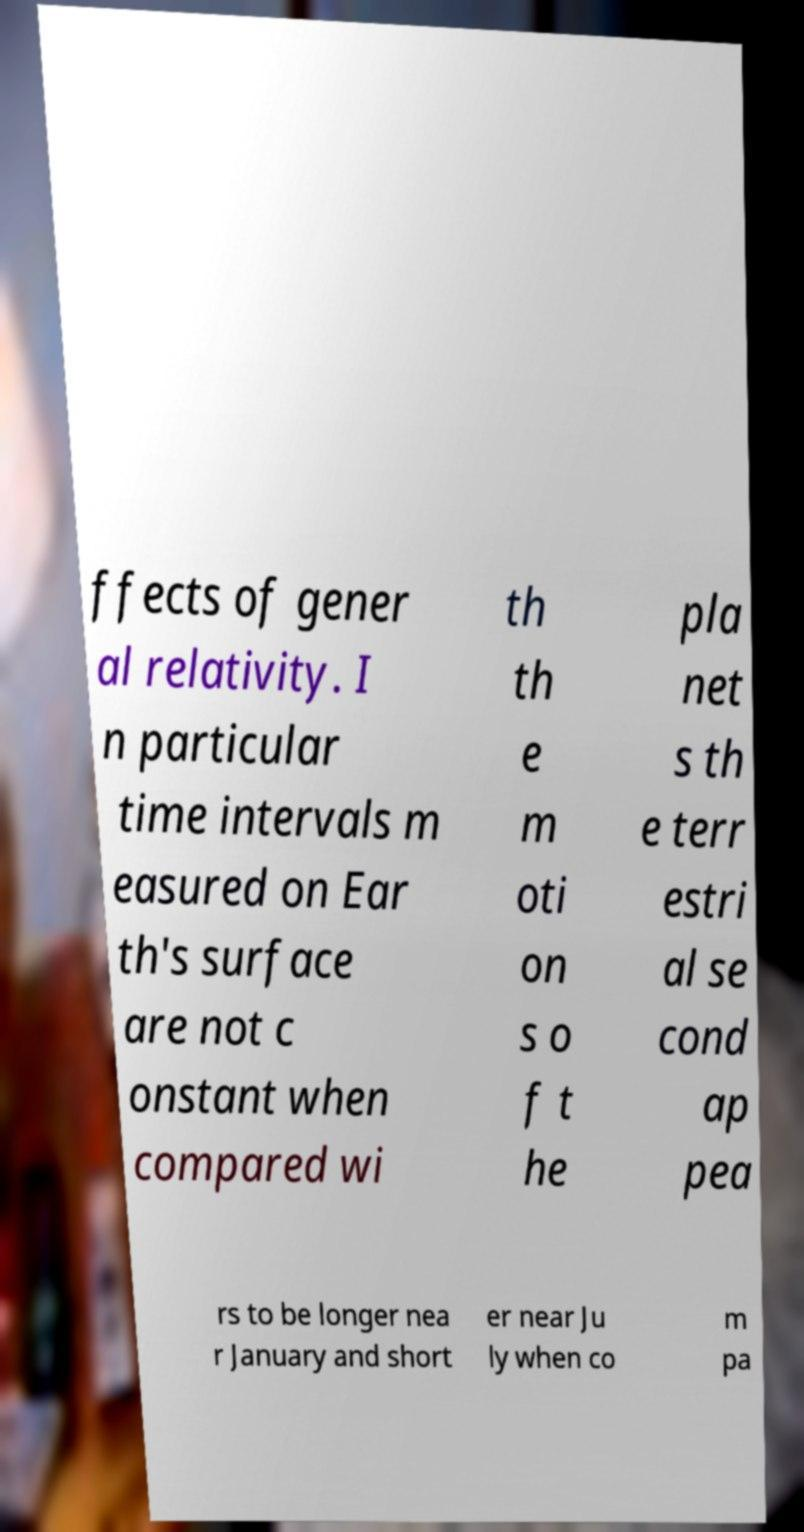There's text embedded in this image that I need extracted. Can you transcribe it verbatim? ffects of gener al relativity. I n particular time intervals m easured on Ear th's surface are not c onstant when compared wi th th e m oti on s o f t he pla net s th e terr estri al se cond ap pea rs to be longer nea r January and short er near Ju ly when co m pa 